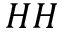<formula> <loc_0><loc_0><loc_500><loc_500>H H</formula> 